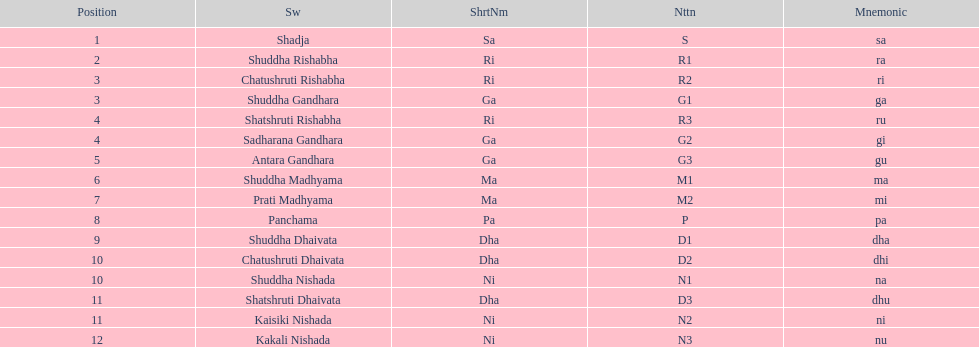How many swaras do not have dhaivata in their name? 13. 